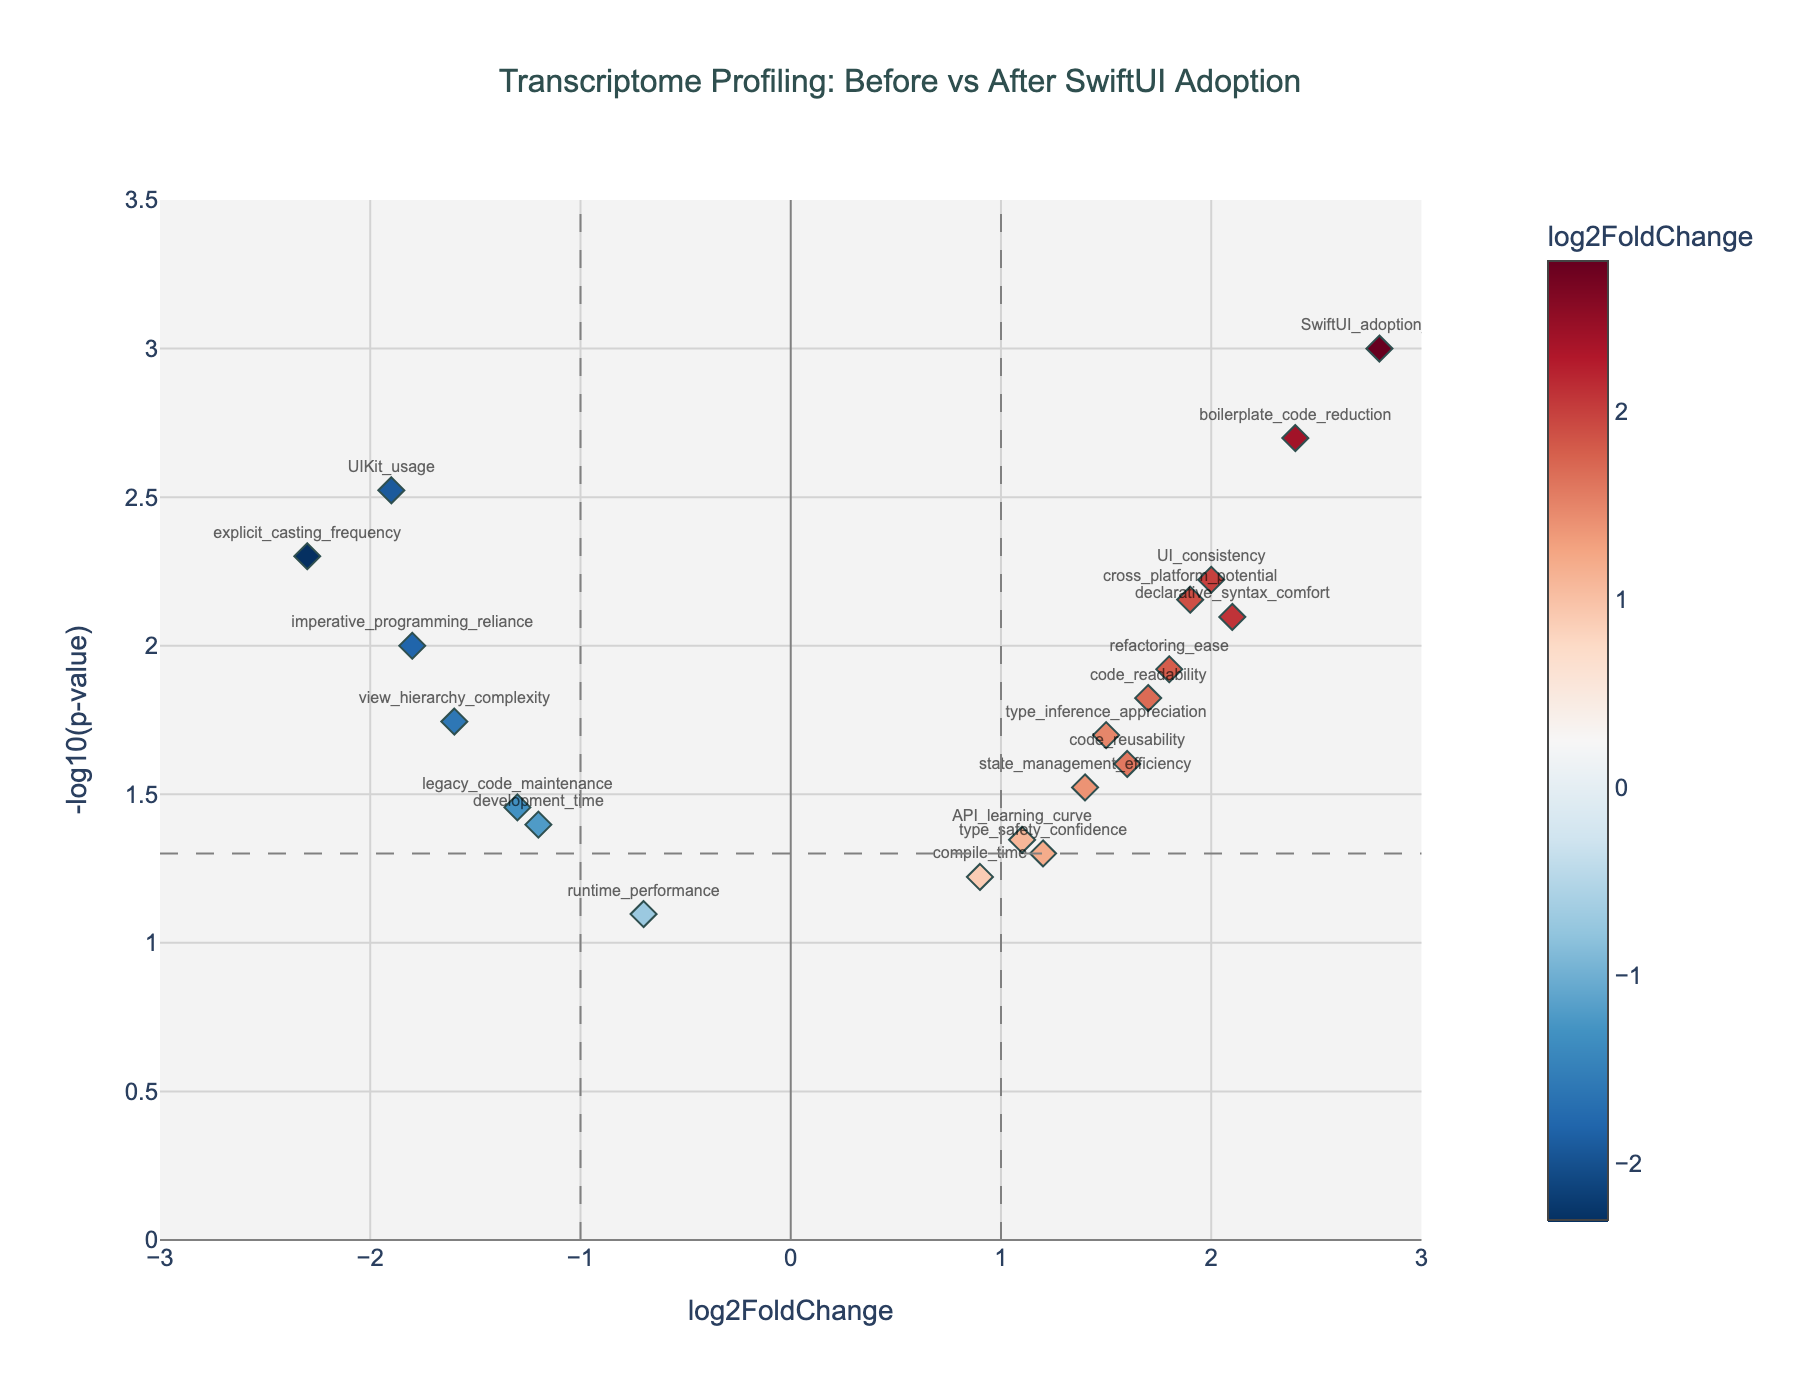what is the title of the plot? The title can be found at the top of the plot, describing what the plot represents. It is written in large, dark grey letters.
Answer: Transcriptome Profiling: Before vs After SwiftUI Adoption how many data points are there in total? The total number of data points corresponds to the number of markers shown on the plot.
Answer: 20 which gene shows the highest positive log2 fold change? In the plot, the gene with the highest positive log2FoldChange will be the one that is farthest to the right on the x-axis.
Answer: SwiftUI_adoption_rate which gene has the largest negative log2 fold change? To find the gene with the largest negative log2FoldChange, look for the point farthest to the left on the x-axis.
Answer: explicit_casting_frequency what is the color of the marker with a log2 fold change of 2.1? The color of markers varies depending on the log2FoldChange value, using a color scale. Find the marker corresponding to a log2FoldChange of 2.1 to determine its color.
Answer: Light Red which genes have a p-value less than 0.01? To find genes with a p-value less than 0.01, locate the markers above the horizontal line corresponding to -log10(0.01), which appears at a y-value of 2 on the plot.
Answer: SwiftUI_adoption_rate, UIKit_usage, explicit_casting_frequency, declarative_syntax_comfort, view_hierarchy_complexity, cross_platform_potential, UI_consistency, boilerplate_code_reduction which gene shows the highest -log10(p-value)? The gene with the highest -log10(p-value) will be the tallest marker on the plot, which means it is the highest point on the y-axis.
Answer: SwiftUI_adoption_rate how many genes exhibit a log2 fold change between -1 and 1 and a p-value less than 0.05? To find this, count the markers within the x-axis range of -1 to 1 and y-axis value above the horizontal line at -log10(0.05) which is 1.3.
Answer: 2 how many genes have a positive log2 fold change and a p-value less than 0.05? Count the markers on the right side of the y-axis (positive log2FoldChange) and above the horizontal line indicating -log10(0.05) which is at a y-value of 1.3.
Answer: 8 compare the log2 fold changes of 'declarative_syntax_comfort' and 'view_hierarchy_complexity'. Which one is higher? Check the x-axis positions of both genes. The gene further to the right has a higher log2FoldChange value.
Answer: declarative_syntax_comfort 